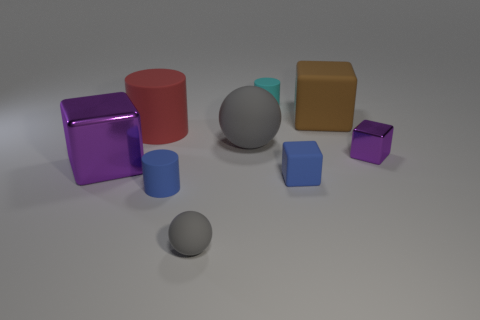Is there anything else that has the same shape as the large brown matte object?
Make the answer very short. Yes. There is another metallic thing that is the same shape as the small purple metallic object; what is its color?
Your answer should be very brief. Purple. What is the material of the big cube behind the large red object?
Keep it short and to the point. Rubber. The tiny sphere has what color?
Your answer should be compact. Gray. There is a blue rubber object that is to the left of the cyan cylinder; is it the same size as the small purple thing?
Ensure brevity in your answer.  Yes. The cylinder that is right of the ball that is behind the gray thing that is in front of the tiny purple metallic thing is made of what material?
Provide a short and direct response. Rubber. There is a large cube that is on the left side of the brown matte object; is it the same color as the tiny cube behind the big purple cube?
Provide a short and direct response. Yes. What is the material of the small cylinder that is behind the big cube right of the cyan cylinder?
Provide a short and direct response. Rubber. What color is the ball that is the same size as the red cylinder?
Provide a succinct answer. Gray. There is a red object; is it the same shape as the blue object right of the big gray matte thing?
Your answer should be very brief. No. 